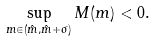<formula> <loc_0><loc_0><loc_500><loc_500>\sup _ { m \in ( \hat { m } , \hat { m } + \sigma ) } M ( m ) < 0 .</formula> 